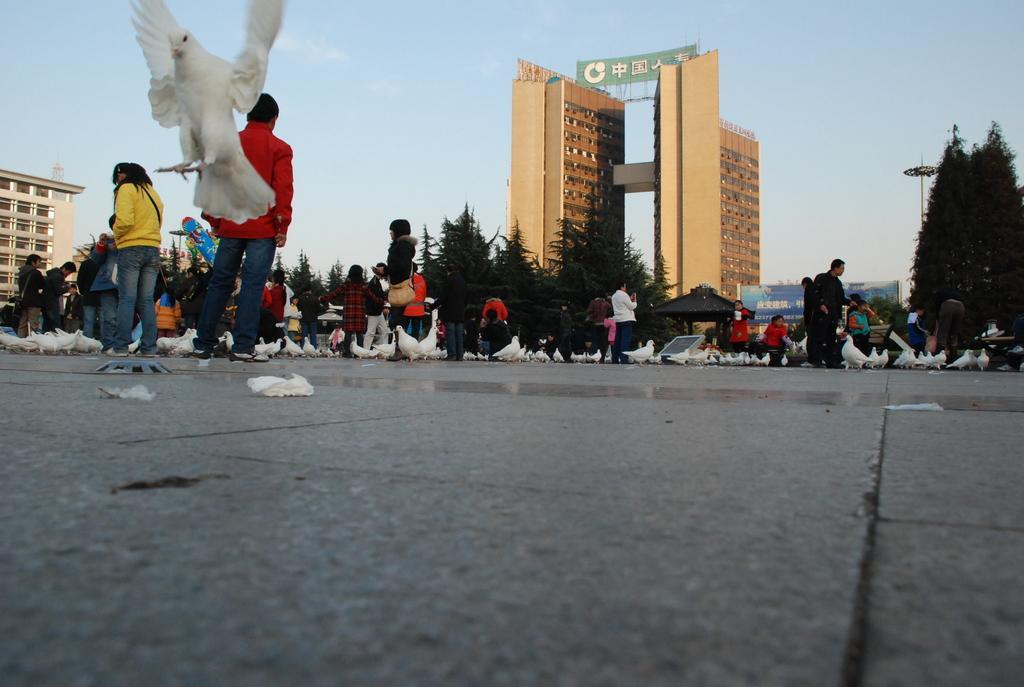Could you give a brief overview of what you see in this image? In this picture, we can see a group of people standing on the path and birds and a bird is flying in the air. In front of the people there are trees, building, hoarding and a sky. 